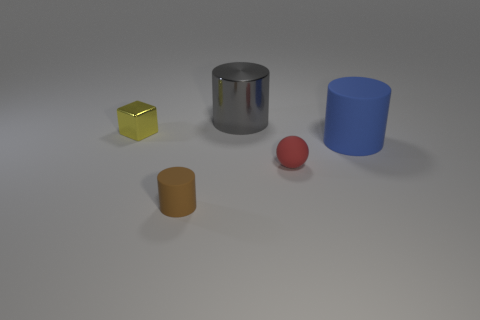What number of other cylinders are the same size as the blue matte cylinder?
Your answer should be very brief. 1. Does the object that is in front of the red matte thing have the same material as the big blue thing?
Your answer should be very brief. Yes. Are there any big purple matte cylinders?
Your answer should be compact. No. What is the size of the yellow cube that is made of the same material as the large gray cylinder?
Your answer should be very brief. Small. Is there a matte object that has the same color as the metal cylinder?
Provide a short and direct response. No. Does the tiny object that is behind the big blue object have the same color as the rubber thing in front of the rubber sphere?
Your answer should be very brief. No. Is there a brown cylinder made of the same material as the blue cylinder?
Keep it short and to the point. Yes. The small metal block is what color?
Offer a terse response. Yellow. How big is the matte cylinder that is right of the large cylinder left of the big thing that is in front of the small yellow shiny object?
Offer a terse response. Large. What number of other objects are the same shape as the big gray thing?
Keep it short and to the point. 2. 